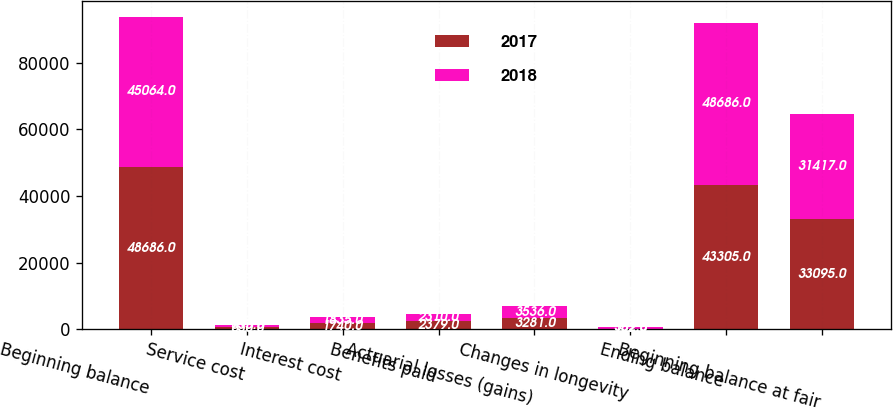Convert chart to OTSL. <chart><loc_0><loc_0><loc_500><loc_500><stacked_bar_chart><ecel><fcel>Beginning balance<fcel>Service cost<fcel>Interest cost<fcel>Benefits paid<fcel>Actuarial losses (gains)<fcel>Changes in longevity<fcel>Ending balance<fcel>Beginning balance at fair<nl><fcel>2017<fcel>48686<fcel>630<fcel>1740<fcel>2379<fcel>3281<fcel>162<fcel>43305<fcel>33095<nl><fcel>2018<fcel>45064<fcel>635<fcel>1835<fcel>2310<fcel>3536<fcel>352<fcel>48686<fcel>31417<nl></chart> 